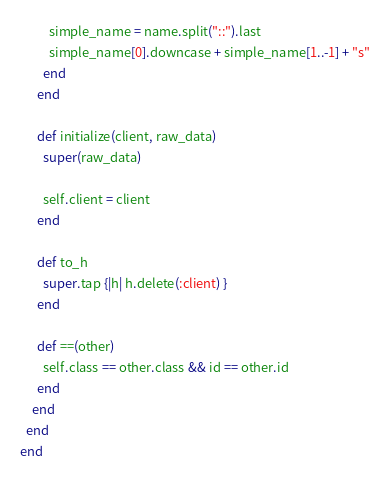Convert code to text. <code><loc_0><loc_0><loc_500><loc_500><_Ruby_>          simple_name = name.split("::").last
          simple_name[0].downcase + simple_name[1..-1] + "s"
        end
      end

      def initialize(client, raw_data)
        super(raw_data)

        self.client = client
      end

      def to_h
        super.tap {|h| h.delete(:client) }
      end

      def ==(other)
        self.class == other.class && id == other.id
      end
    end
  end
end
</code> 